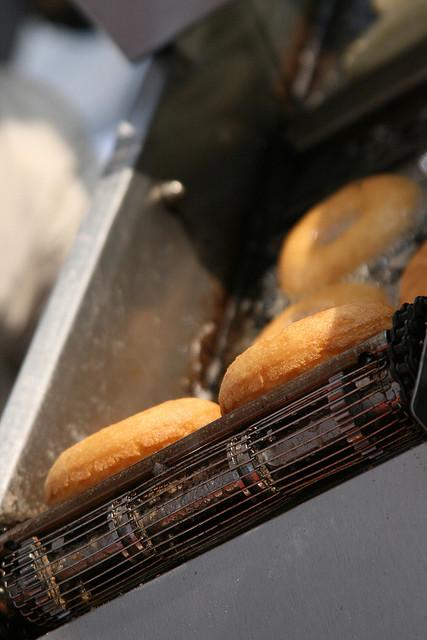Are the donuts ready?
Concise answer only. Yes. Are these donuts fresh?
Answer briefly. Yes. Do the donuts look ready?
Be succinct. Yes. 